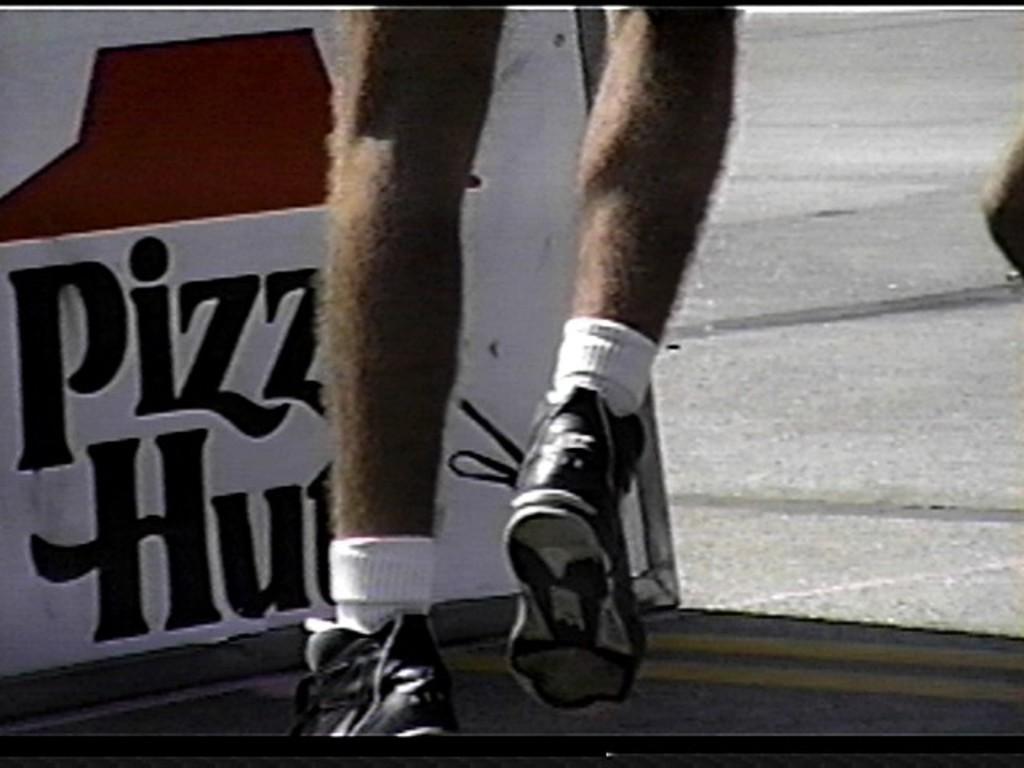Could you give a brief overview of what you see in this image? Here I can see a person's foot wearing socks and shoes. It seems like this person is running on the road. On the right side, I can see a person's hand and on the left side there is a board on which I can see some text. 